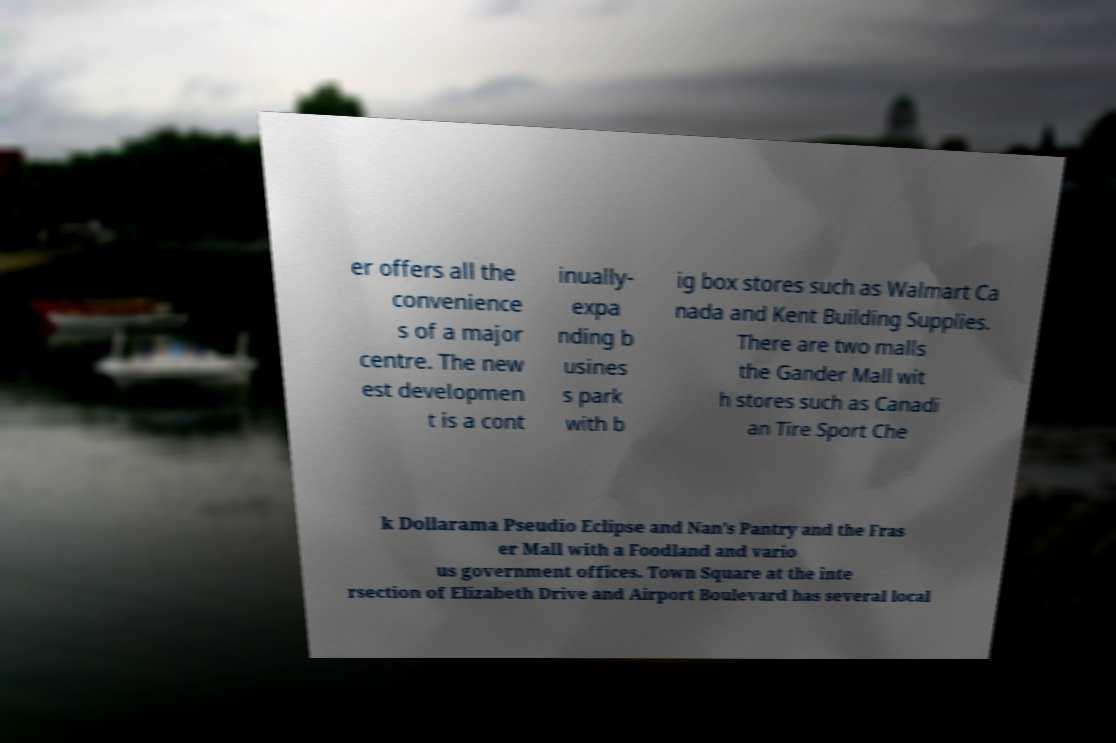Can you accurately transcribe the text from the provided image for me? er offers all the convenience s of a major centre. The new est developmen t is a cont inually- expa nding b usines s park with b ig box stores such as Walmart Ca nada and Kent Building Supplies. There are two malls the Gander Mall wit h stores such as Canadi an Tire Sport Che k Dollarama Pseudio Eclipse and Nan's Pantry and the Fras er Mall with a Foodland and vario us government offices. Town Square at the inte rsection of Elizabeth Drive and Airport Boulevard has several local 